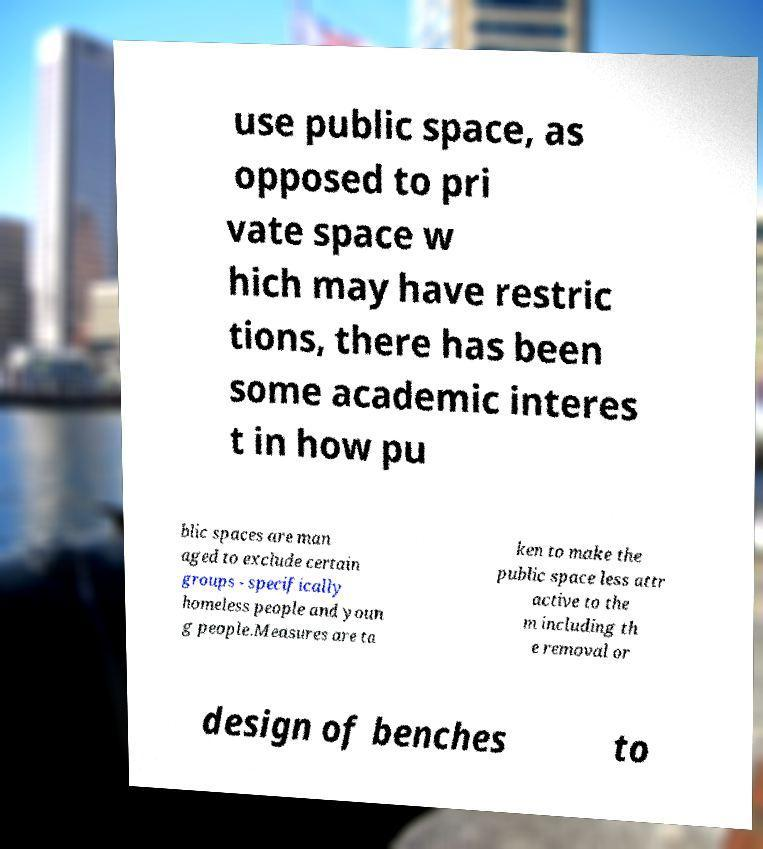There's text embedded in this image that I need extracted. Can you transcribe it verbatim? use public space, as opposed to pri vate space w hich may have restric tions, there has been some academic interes t in how pu blic spaces are man aged to exclude certain groups - specifically homeless people and youn g people.Measures are ta ken to make the public space less attr active to the m including th e removal or design of benches to 